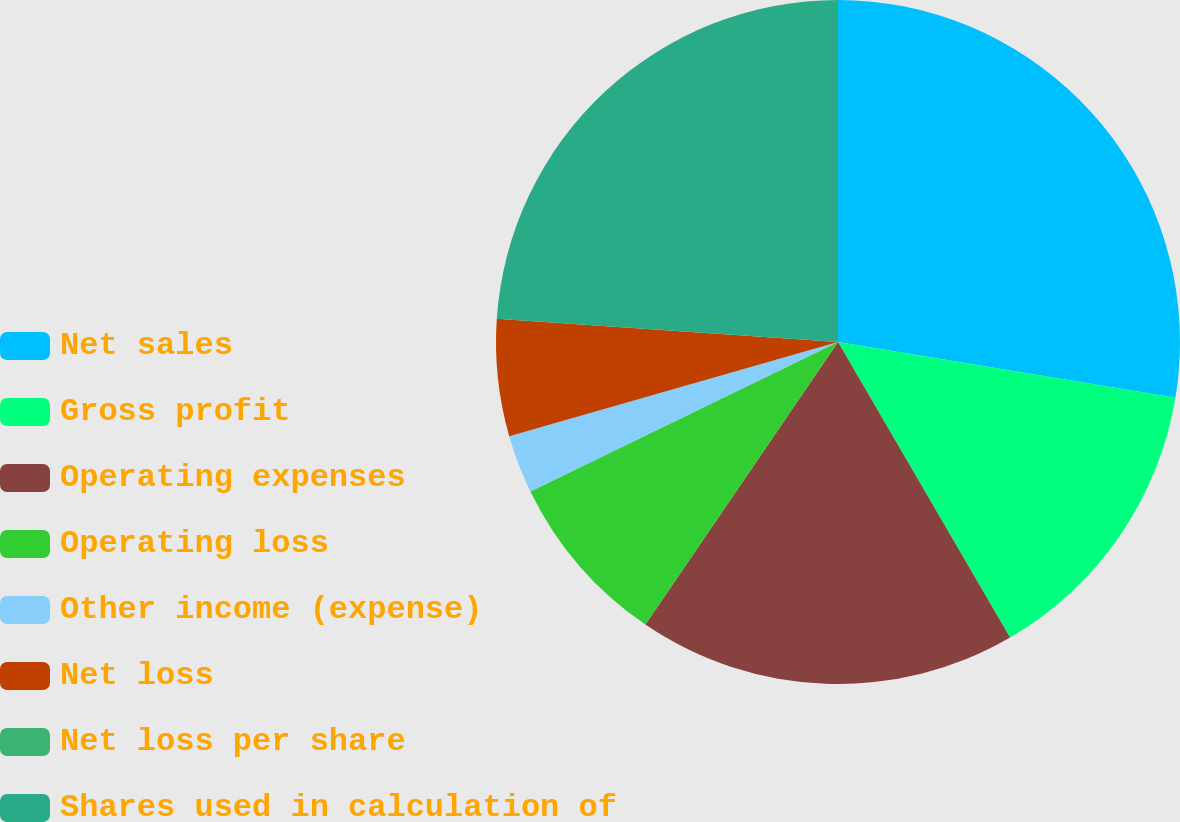Convert chart to OTSL. <chart><loc_0><loc_0><loc_500><loc_500><pie_chart><fcel>Net sales<fcel>Gross profit<fcel>Operating expenses<fcel>Operating loss<fcel>Other income (expense)<fcel>Net loss<fcel>Net loss per share<fcel>Shares used in calculation of<nl><fcel>27.61%<fcel>14.0%<fcel>17.91%<fcel>8.28%<fcel>2.76%<fcel>5.52%<fcel>0.0%<fcel>23.92%<nl></chart> 